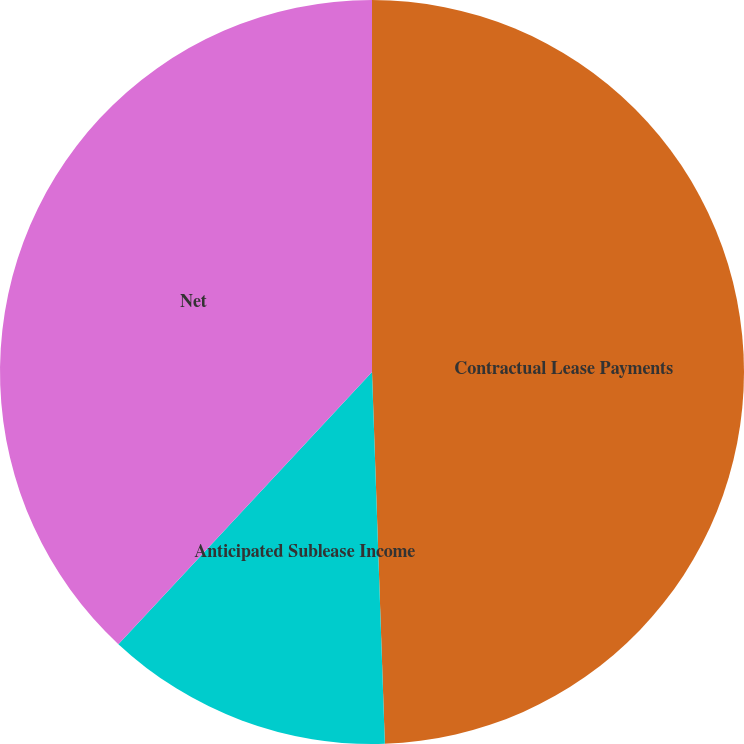Convert chart. <chart><loc_0><loc_0><loc_500><loc_500><pie_chart><fcel>Contractual Lease Payments<fcel>Anticipated Sublease Income<fcel>Net<nl><fcel>49.45%<fcel>12.49%<fcel>38.06%<nl></chart> 